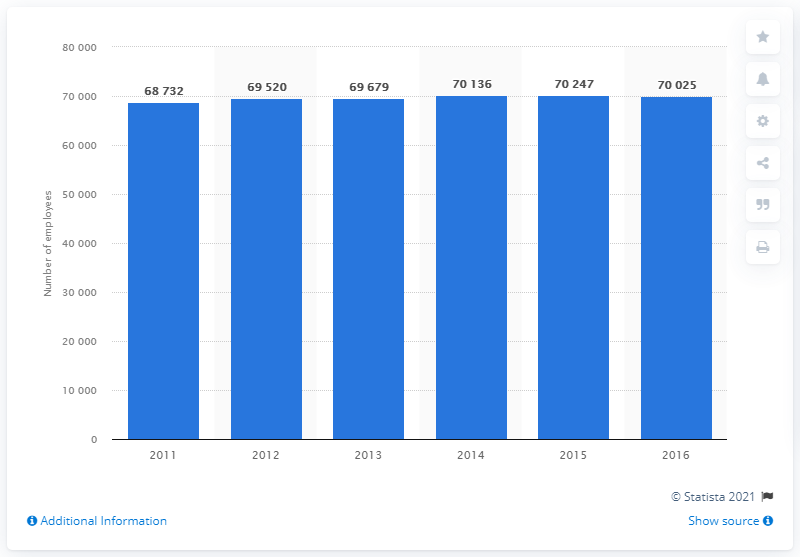Outline some significant characteristics in this image. In 2015, there were approximately 70,025 pharmacists employed in the healthcare sector in France. 